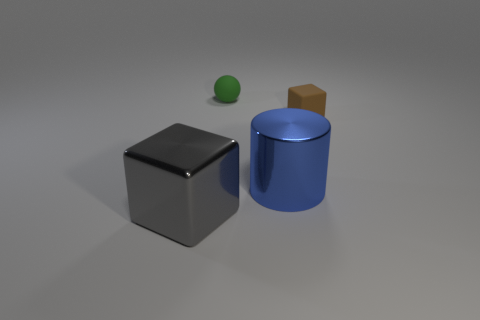Can you explain the lighting in this scene? Certainly! In this scene, there's a single, diffuse light source coming from the top right corner, as evidenced by the soft shadows cast by the objects on the ground and their gently illuminated surfaces. The softness of the shadows suggests that the light is not overly harsh and that it is spread out over the area, possibly simulating an overcast sky or indirect daylight. 